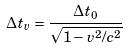Convert formula to latex. <formula><loc_0><loc_0><loc_500><loc_500>\Delta t _ { v } = \frac { \Delta t _ { 0 } } { \sqrt { 1 - v ^ { 2 } / c ^ { 2 } } }</formula> 